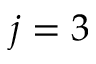<formula> <loc_0><loc_0><loc_500><loc_500>j = 3</formula> 